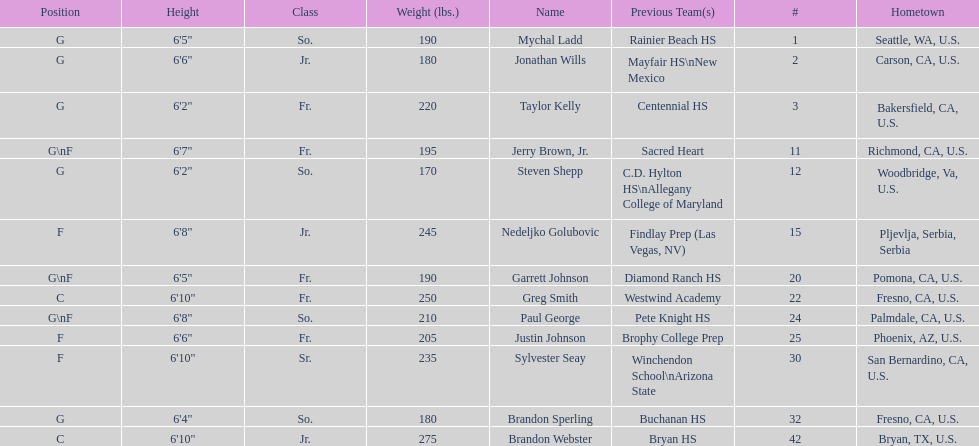After nedelijko golubovic, who is the next heaviest player? Sylvester Seay. 